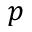Convert formula to latex. <formula><loc_0><loc_0><loc_500><loc_500>p</formula> 